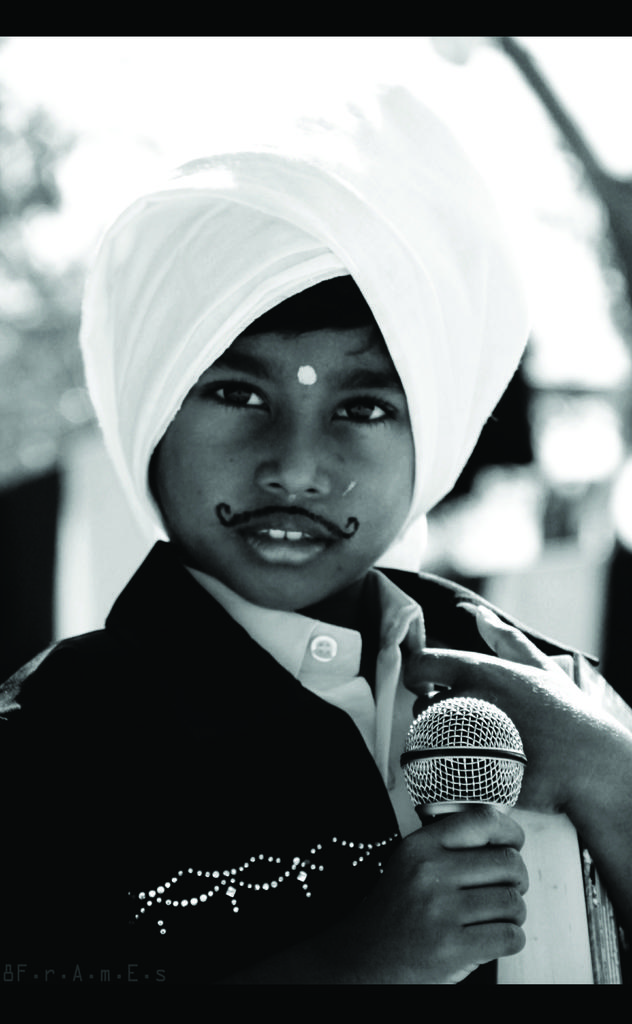Who is the main subject in the image? There is a boy in the image. What is the boy holding in the image? The boy is holding a microphone. What type of celery is the boy using to adjust the sound levels in the image? There is no celery present in the image, and the boy is not adjusting any sound levels. 